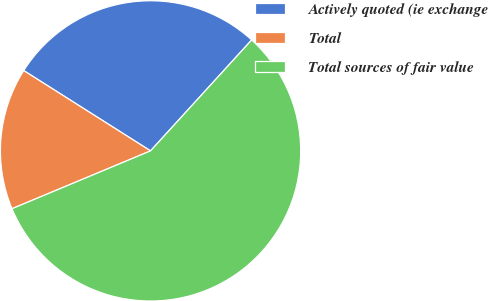<chart> <loc_0><loc_0><loc_500><loc_500><pie_chart><fcel>Actively quoted (ie exchange<fcel>Total<fcel>Total sources of fair value<nl><fcel>27.78%<fcel>15.28%<fcel>56.94%<nl></chart> 